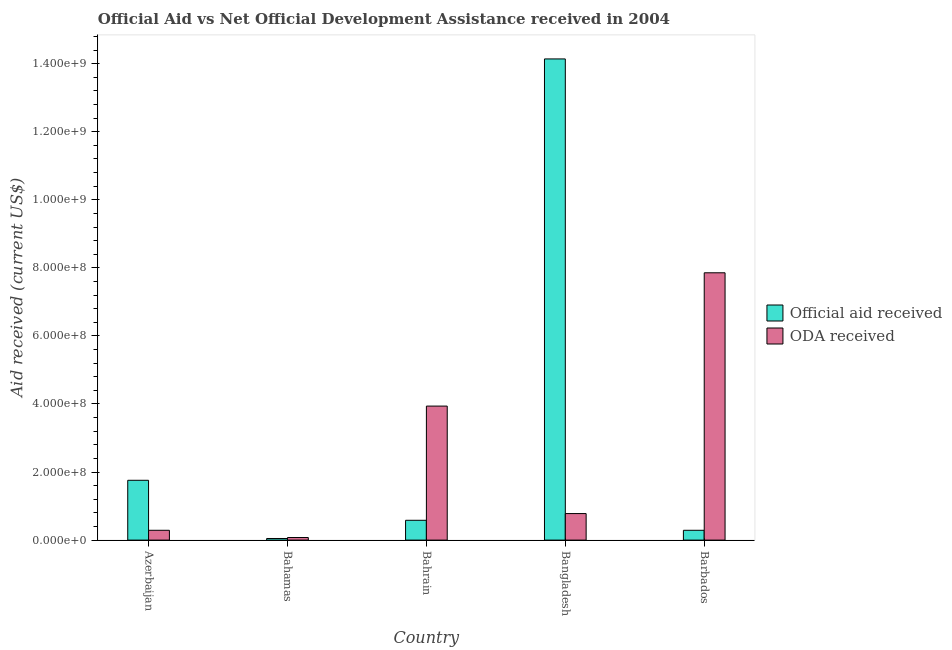How many groups of bars are there?
Provide a short and direct response. 5. Are the number of bars per tick equal to the number of legend labels?
Provide a succinct answer. Yes. How many bars are there on the 5th tick from the left?
Your answer should be compact. 2. How many bars are there on the 2nd tick from the right?
Offer a terse response. 2. What is the label of the 3rd group of bars from the left?
Provide a short and direct response. Bahrain. In how many cases, is the number of bars for a given country not equal to the number of legend labels?
Keep it short and to the point. 0. What is the oda received in Barbados?
Ensure brevity in your answer.  7.85e+08. Across all countries, what is the maximum official aid received?
Offer a terse response. 1.41e+09. Across all countries, what is the minimum oda received?
Make the answer very short. 7.58e+06. In which country was the official aid received maximum?
Provide a short and direct response. Bangladesh. In which country was the oda received minimum?
Give a very brief answer. Bahamas. What is the total oda received in the graph?
Ensure brevity in your answer.  1.29e+09. What is the difference between the oda received in Bangladesh and that in Barbados?
Provide a short and direct response. -7.07e+08. What is the difference between the official aid received in Bangladesh and the oda received in Barbados?
Give a very brief answer. 6.28e+08. What is the average oda received per country?
Provide a succinct answer. 2.59e+08. What is the difference between the official aid received and oda received in Bahrain?
Provide a succinct answer. -3.36e+08. What is the ratio of the oda received in Bahamas to that in Bangladesh?
Keep it short and to the point. 0.1. Is the oda received in Azerbaijan less than that in Bahamas?
Ensure brevity in your answer.  No. Is the difference between the official aid received in Bahamas and Bahrain greater than the difference between the oda received in Bahamas and Bahrain?
Ensure brevity in your answer.  Yes. What is the difference between the highest and the second highest official aid received?
Provide a short and direct response. 1.24e+09. What is the difference between the highest and the lowest oda received?
Provide a short and direct response. 7.78e+08. In how many countries, is the oda received greater than the average oda received taken over all countries?
Your response must be concise. 2. What does the 1st bar from the left in Barbados represents?
Your response must be concise. Official aid received. What does the 2nd bar from the right in Azerbaijan represents?
Ensure brevity in your answer.  Official aid received. How many countries are there in the graph?
Your answer should be compact. 5. What is the difference between two consecutive major ticks on the Y-axis?
Ensure brevity in your answer.  2.00e+08. Does the graph contain grids?
Provide a short and direct response. No. How many legend labels are there?
Make the answer very short. 2. What is the title of the graph?
Your response must be concise. Official Aid vs Net Official Development Assistance received in 2004 . What is the label or title of the Y-axis?
Your answer should be very brief. Aid received (current US$). What is the Aid received (current US$) of Official aid received in Azerbaijan?
Your response must be concise. 1.76e+08. What is the Aid received (current US$) of ODA received in Azerbaijan?
Keep it short and to the point. 2.88e+07. What is the Aid received (current US$) in Official aid received in Bahamas?
Ensure brevity in your answer.  4.75e+06. What is the Aid received (current US$) in ODA received in Bahamas?
Provide a short and direct response. 7.58e+06. What is the Aid received (current US$) of Official aid received in Bahrain?
Keep it short and to the point. 5.82e+07. What is the Aid received (current US$) in ODA received in Bahrain?
Offer a very short reply. 3.94e+08. What is the Aid received (current US$) in Official aid received in Bangladesh?
Give a very brief answer. 1.41e+09. What is the Aid received (current US$) in ODA received in Bangladesh?
Make the answer very short. 7.80e+07. What is the Aid received (current US$) in Official aid received in Barbados?
Your answer should be compact. 2.88e+07. What is the Aid received (current US$) in ODA received in Barbados?
Give a very brief answer. 7.85e+08. Across all countries, what is the maximum Aid received (current US$) of Official aid received?
Provide a succinct answer. 1.41e+09. Across all countries, what is the maximum Aid received (current US$) of ODA received?
Offer a terse response. 7.85e+08. Across all countries, what is the minimum Aid received (current US$) in Official aid received?
Offer a terse response. 4.75e+06. Across all countries, what is the minimum Aid received (current US$) in ODA received?
Provide a short and direct response. 7.58e+06. What is the total Aid received (current US$) of Official aid received in the graph?
Provide a short and direct response. 1.68e+09. What is the total Aid received (current US$) in ODA received in the graph?
Offer a terse response. 1.29e+09. What is the difference between the Aid received (current US$) of Official aid received in Azerbaijan and that in Bahamas?
Provide a short and direct response. 1.71e+08. What is the difference between the Aid received (current US$) in ODA received in Azerbaijan and that in Bahamas?
Offer a terse response. 2.12e+07. What is the difference between the Aid received (current US$) of Official aid received in Azerbaijan and that in Bahrain?
Your answer should be very brief. 1.18e+08. What is the difference between the Aid received (current US$) in ODA received in Azerbaijan and that in Bahrain?
Your response must be concise. -3.65e+08. What is the difference between the Aid received (current US$) in Official aid received in Azerbaijan and that in Bangladesh?
Make the answer very short. -1.24e+09. What is the difference between the Aid received (current US$) in ODA received in Azerbaijan and that in Bangladesh?
Your answer should be very brief. -4.92e+07. What is the difference between the Aid received (current US$) of Official aid received in Azerbaijan and that in Barbados?
Make the answer very short. 1.47e+08. What is the difference between the Aid received (current US$) in ODA received in Azerbaijan and that in Barbados?
Your answer should be compact. -7.57e+08. What is the difference between the Aid received (current US$) of Official aid received in Bahamas and that in Bahrain?
Your answer should be very brief. -5.35e+07. What is the difference between the Aid received (current US$) in ODA received in Bahamas and that in Bahrain?
Make the answer very short. -3.86e+08. What is the difference between the Aid received (current US$) in Official aid received in Bahamas and that in Bangladesh?
Ensure brevity in your answer.  -1.41e+09. What is the difference between the Aid received (current US$) of ODA received in Bahamas and that in Bangladesh?
Your answer should be very brief. -7.04e+07. What is the difference between the Aid received (current US$) in Official aid received in Bahamas and that in Barbados?
Keep it short and to the point. -2.41e+07. What is the difference between the Aid received (current US$) in ODA received in Bahamas and that in Barbados?
Your answer should be compact. -7.78e+08. What is the difference between the Aid received (current US$) of Official aid received in Bahrain and that in Bangladesh?
Your answer should be very brief. -1.36e+09. What is the difference between the Aid received (current US$) of ODA received in Bahrain and that in Bangladesh?
Make the answer very short. 3.16e+08. What is the difference between the Aid received (current US$) of Official aid received in Bahrain and that in Barbados?
Your response must be concise. 2.94e+07. What is the difference between the Aid received (current US$) of ODA received in Bahrain and that in Barbados?
Your response must be concise. -3.92e+08. What is the difference between the Aid received (current US$) of Official aid received in Bangladesh and that in Barbados?
Give a very brief answer. 1.39e+09. What is the difference between the Aid received (current US$) in ODA received in Bangladesh and that in Barbados?
Give a very brief answer. -7.07e+08. What is the difference between the Aid received (current US$) in Official aid received in Azerbaijan and the Aid received (current US$) in ODA received in Bahamas?
Make the answer very short. 1.68e+08. What is the difference between the Aid received (current US$) of Official aid received in Azerbaijan and the Aid received (current US$) of ODA received in Bahrain?
Your response must be concise. -2.18e+08. What is the difference between the Aid received (current US$) in Official aid received in Azerbaijan and the Aid received (current US$) in ODA received in Bangladesh?
Provide a succinct answer. 9.78e+07. What is the difference between the Aid received (current US$) in Official aid received in Azerbaijan and the Aid received (current US$) in ODA received in Barbados?
Your answer should be very brief. -6.10e+08. What is the difference between the Aid received (current US$) in Official aid received in Bahamas and the Aid received (current US$) in ODA received in Bahrain?
Your answer should be very brief. -3.89e+08. What is the difference between the Aid received (current US$) in Official aid received in Bahamas and the Aid received (current US$) in ODA received in Bangladesh?
Your response must be concise. -7.32e+07. What is the difference between the Aid received (current US$) of Official aid received in Bahamas and the Aid received (current US$) of ODA received in Barbados?
Your answer should be compact. -7.81e+08. What is the difference between the Aid received (current US$) of Official aid received in Bahrain and the Aid received (current US$) of ODA received in Bangladesh?
Your answer should be very brief. -1.98e+07. What is the difference between the Aid received (current US$) of Official aid received in Bahrain and the Aid received (current US$) of ODA received in Barbados?
Your response must be concise. -7.27e+08. What is the difference between the Aid received (current US$) in Official aid received in Bangladesh and the Aid received (current US$) in ODA received in Barbados?
Provide a succinct answer. 6.28e+08. What is the average Aid received (current US$) of Official aid received per country?
Your response must be concise. 3.36e+08. What is the average Aid received (current US$) in ODA received per country?
Provide a short and direct response. 2.59e+08. What is the difference between the Aid received (current US$) in Official aid received and Aid received (current US$) in ODA received in Azerbaijan?
Provide a succinct answer. 1.47e+08. What is the difference between the Aid received (current US$) of Official aid received and Aid received (current US$) of ODA received in Bahamas?
Give a very brief answer. -2.83e+06. What is the difference between the Aid received (current US$) of Official aid received and Aid received (current US$) of ODA received in Bahrain?
Offer a very short reply. -3.36e+08. What is the difference between the Aid received (current US$) of Official aid received and Aid received (current US$) of ODA received in Bangladesh?
Your answer should be very brief. 1.34e+09. What is the difference between the Aid received (current US$) in Official aid received and Aid received (current US$) in ODA received in Barbados?
Your response must be concise. -7.57e+08. What is the ratio of the Aid received (current US$) of Official aid received in Azerbaijan to that in Bahamas?
Give a very brief answer. 37. What is the ratio of the Aid received (current US$) in ODA received in Azerbaijan to that in Bahamas?
Give a very brief answer. 3.8. What is the ratio of the Aid received (current US$) of Official aid received in Azerbaijan to that in Bahrain?
Offer a very short reply. 3.02. What is the ratio of the Aid received (current US$) in ODA received in Azerbaijan to that in Bahrain?
Offer a very short reply. 0.07. What is the ratio of the Aid received (current US$) in Official aid received in Azerbaijan to that in Bangladesh?
Make the answer very short. 0.12. What is the ratio of the Aid received (current US$) of ODA received in Azerbaijan to that in Bangladesh?
Provide a short and direct response. 0.37. What is the ratio of the Aid received (current US$) in Official aid received in Azerbaijan to that in Barbados?
Ensure brevity in your answer.  6.1. What is the ratio of the Aid received (current US$) in ODA received in Azerbaijan to that in Barbados?
Provide a short and direct response. 0.04. What is the ratio of the Aid received (current US$) of Official aid received in Bahamas to that in Bahrain?
Ensure brevity in your answer.  0.08. What is the ratio of the Aid received (current US$) in ODA received in Bahamas to that in Bahrain?
Give a very brief answer. 0.02. What is the ratio of the Aid received (current US$) in Official aid received in Bahamas to that in Bangladesh?
Give a very brief answer. 0. What is the ratio of the Aid received (current US$) of ODA received in Bahamas to that in Bangladesh?
Provide a short and direct response. 0.1. What is the ratio of the Aid received (current US$) in Official aid received in Bahamas to that in Barbados?
Keep it short and to the point. 0.16. What is the ratio of the Aid received (current US$) in ODA received in Bahamas to that in Barbados?
Offer a very short reply. 0.01. What is the ratio of the Aid received (current US$) of Official aid received in Bahrain to that in Bangladesh?
Your answer should be very brief. 0.04. What is the ratio of the Aid received (current US$) of ODA received in Bahrain to that in Bangladesh?
Offer a very short reply. 5.05. What is the ratio of the Aid received (current US$) in Official aid received in Bahrain to that in Barbados?
Your answer should be compact. 2.02. What is the ratio of the Aid received (current US$) in ODA received in Bahrain to that in Barbados?
Make the answer very short. 0.5. What is the ratio of the Aid received (current US$) in Official aid received in Bangladesh to that in Barbados?
Keep it short and to the point. 49.08. What is the ratio of the Aid received (current US$) in ODA received in Bangladesh to that in Barbados?
Your response must be concise. 0.1. What is the difference between the highest and the second highest Aid received (current US$) in Official aid received?
Your answer should be compact. 1.24e+09. What is the difference between the highest and the second highest Aid received (current US$) in ODA received?
Make the answer very short. 3.92e+08. What is the difference between the highest and the lowest Aid received (current US$) of Official aid received?
Make the answer very short. 1.41e+09. What is the difference between the highest and the lowest Aid received (current US$) in ODA received?
Your answer should be compact. 7.78e+08. 